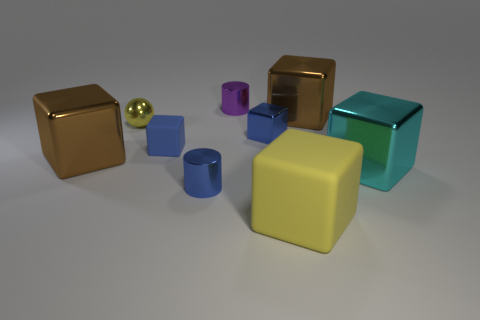What color is the block that is the same size as the blue matte thing?
Your response must be concise. Blue. There is a yellow rubber object to the right of the yellow metal thing; is it the same size as the small purple metal thing?
Ensure brevity in your answer.  No. Do the tiny shiny cube and the metal sphere have the same color?
Provide a short and direct response. No. How many blue things are there?
Your response must be concise. 3. What number of spheres are either tiny brown matte objects or cyan objects?
Provide a short and direct response. 0. There is a small metallic thing right of the purple metal object; how many blue shiny cylinders are on the left side of it?
Provide a short and direct response. 1. Do the ball and the big cyan cube have the same material?
Offer a very short reply. Yes. There is a rubber object that is the same color as the metallic ball; what size is it?
Give a very brief answer. Large. Are there any tiny blue blocks that have the same material as the tiny blue cylinder?
Your response must be concise. Yes. The large cube that is to the left of the small blue metallic thing that is on the right side of the tiny thing that is behind the shiny ball is what color?
Make the answer very short. Brown. 